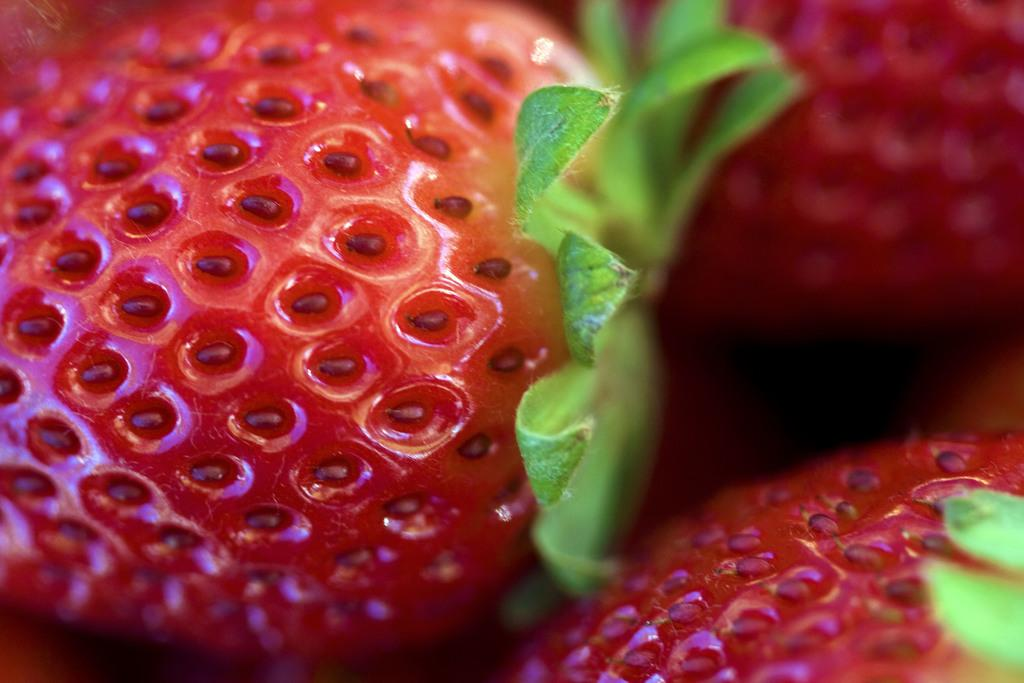What type of fruit is present in the image? There are strawberries in the image. How many horses are visible in the image? There are no horses present in the image; it only features strawberries. What is the belief system of the strawberries in the image? Strawberries do not have a belief system, as they are inanimate objects. 